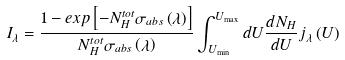Convert formula to latex. <formula><loc_0><loc_0><loc_500><loc_500>I _ { \lambda } = \frac { 1 - e x p \left [ - N _ { H } ^ { t o t } \sigma _ { a b s } \left ( \lambda \right ) \right ] } { N _ { H } ^ { t o t } \sigma _ { a b s } \left ( \lambda \right ) } \int ^ { U _ { \max } } _ { U _ { \min } } d U \frac { d N _ { H } } { d U } j _ { \lambda } \left ( U \right )</formula> 